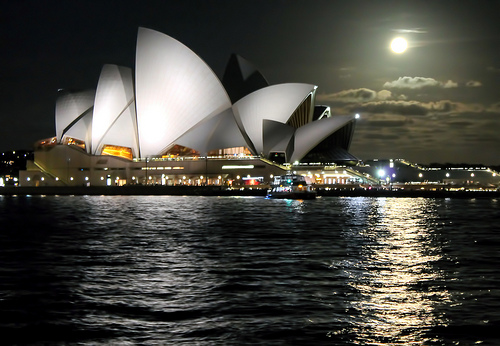<image>
Is the building behind the water? Yes. From this viewpoint, the building is positioned behind the water, with the water partially or fully occluding the building. 